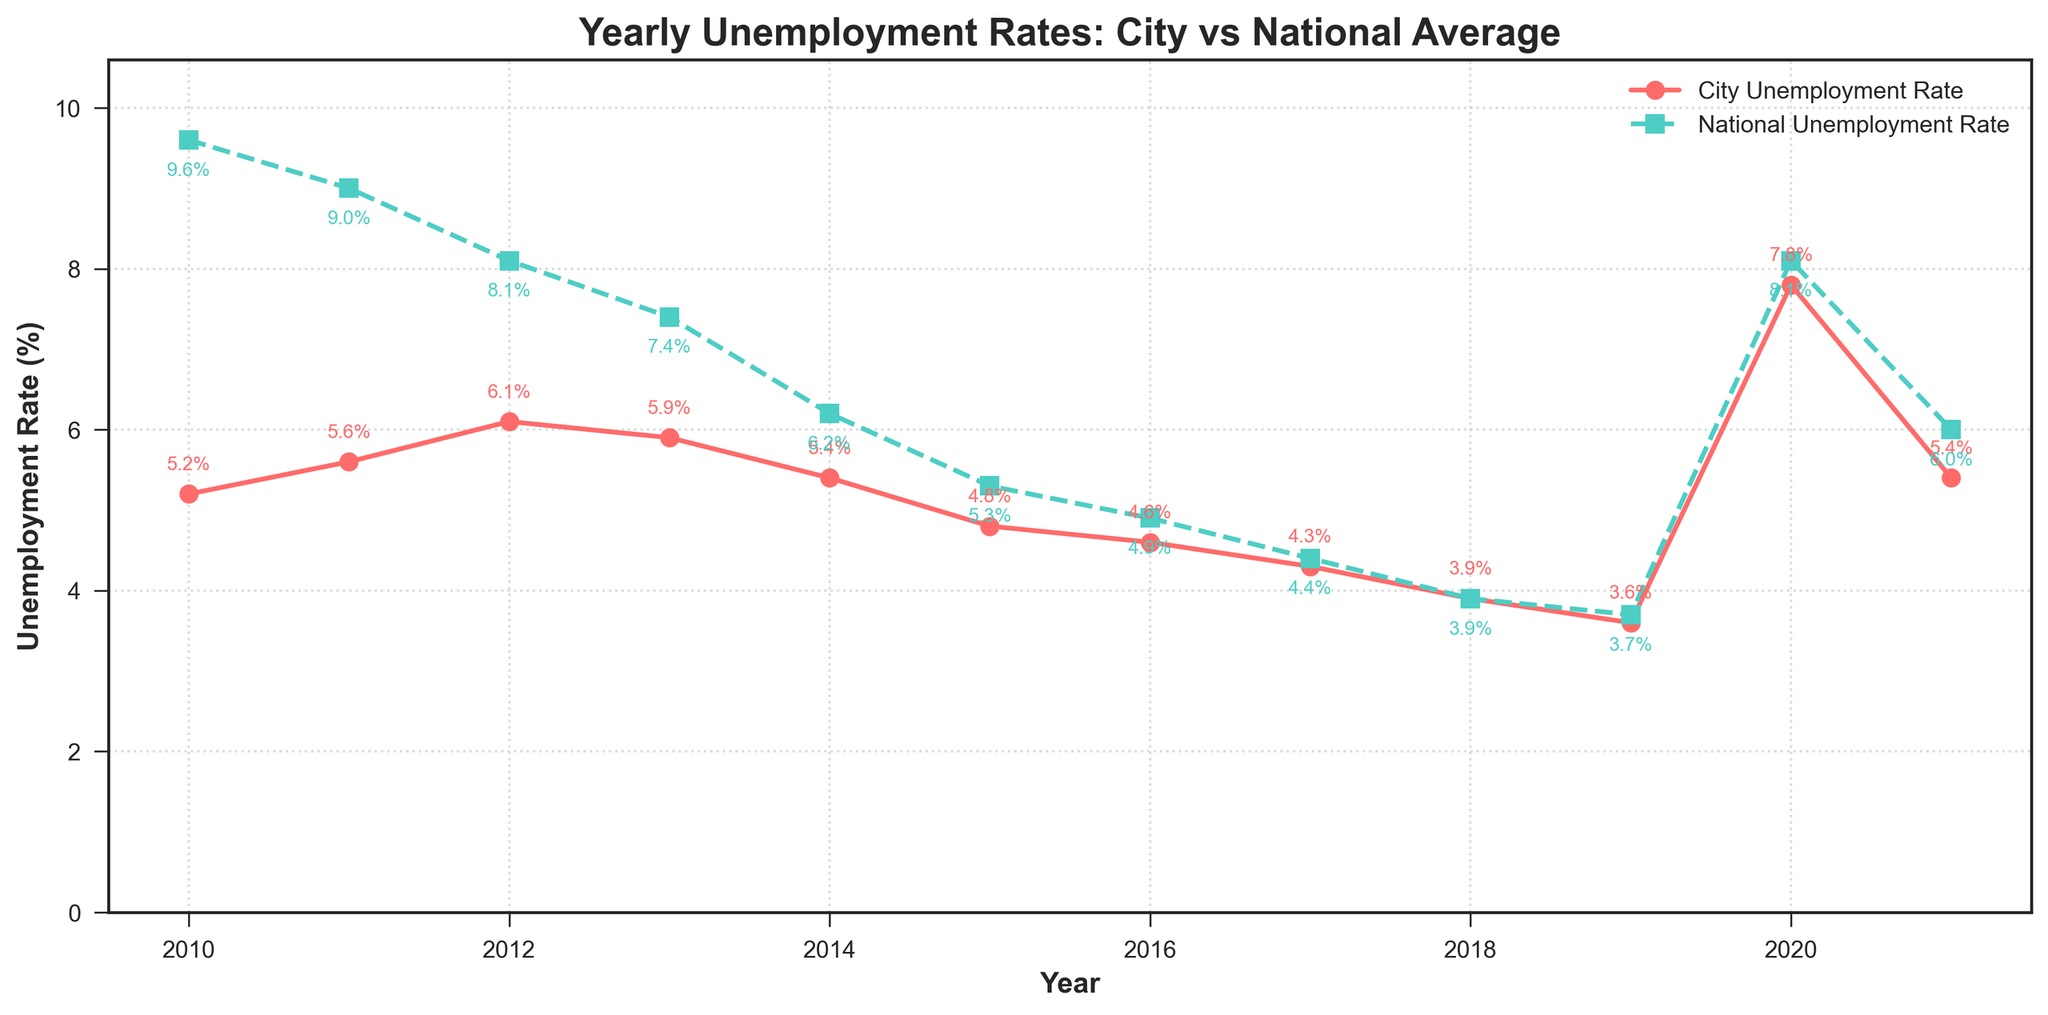What year had the highest city unemployment rate? The figure shows a time series of unemployment rates for both the city and nationally. The highest point on the city's unemployment rate line is in 2020.
Answer: 2020 How does the 2010 national unemployment rate compare to the 2021 national rate? In 2010, the national unemployment rate is 9.6%, while in 2021, it is 6.0%. These values can be directly read from the figure.
Answer: The 2010 rate is higher What is the difference between the city's and national unemployment rates in 2018? The city's unemployment rate in 2018 is 3.9%, and the national rate is also 3.9%. Subtract the national rate from the city rate: 3.9% - 3.9% = 0%.
Answer: 0% Which year shows the smallest difference between the city's unemployment rate and the national average? Examining the figure, the smallest difference is in 2018, where both the city and national unemployment rates are exactly the same at 3.9%.
Answer: 2018 In which years is the city's unemployment rate exactly equal to the national rate? By checking where the two lines intersect, the city’s unemployment rate is equal to the national rate in 2018 and 2019.
Answer: 2018 and 2019 During which year did the city's unemployment rate peak based on the plot? The city’s unemployment rate peaks at its highest point on the line in 2020.
Answer: 2020 How much did the city's unemployment rate decrease from its peak in 2020 to 2021? The city's unemployment rate is 7.8% in 2020 and 5.4% in 2021. The decrease is 7.8% - 5.4% = 2.4%.
Answer: 2.4% What is the trend of the national unemployment rate from 2010 to 2019? Observing the national unemployment rate line, it generally decreases from 9.6% in 2010 to 3.7% in 2019.
Answer: Decreasing How did the difference between the city's and national unemployment rates change from 2017 to 2020? In 2017, the city rate is 4.3% and the national rate is 4.4%, a difference of 0.1%. In 2020, the city rate is 7.8% and the national rate is 8.1%, a difference of 0.3%. The difference increased from 0.1% to 0.3%.
Answer: The difference increased 